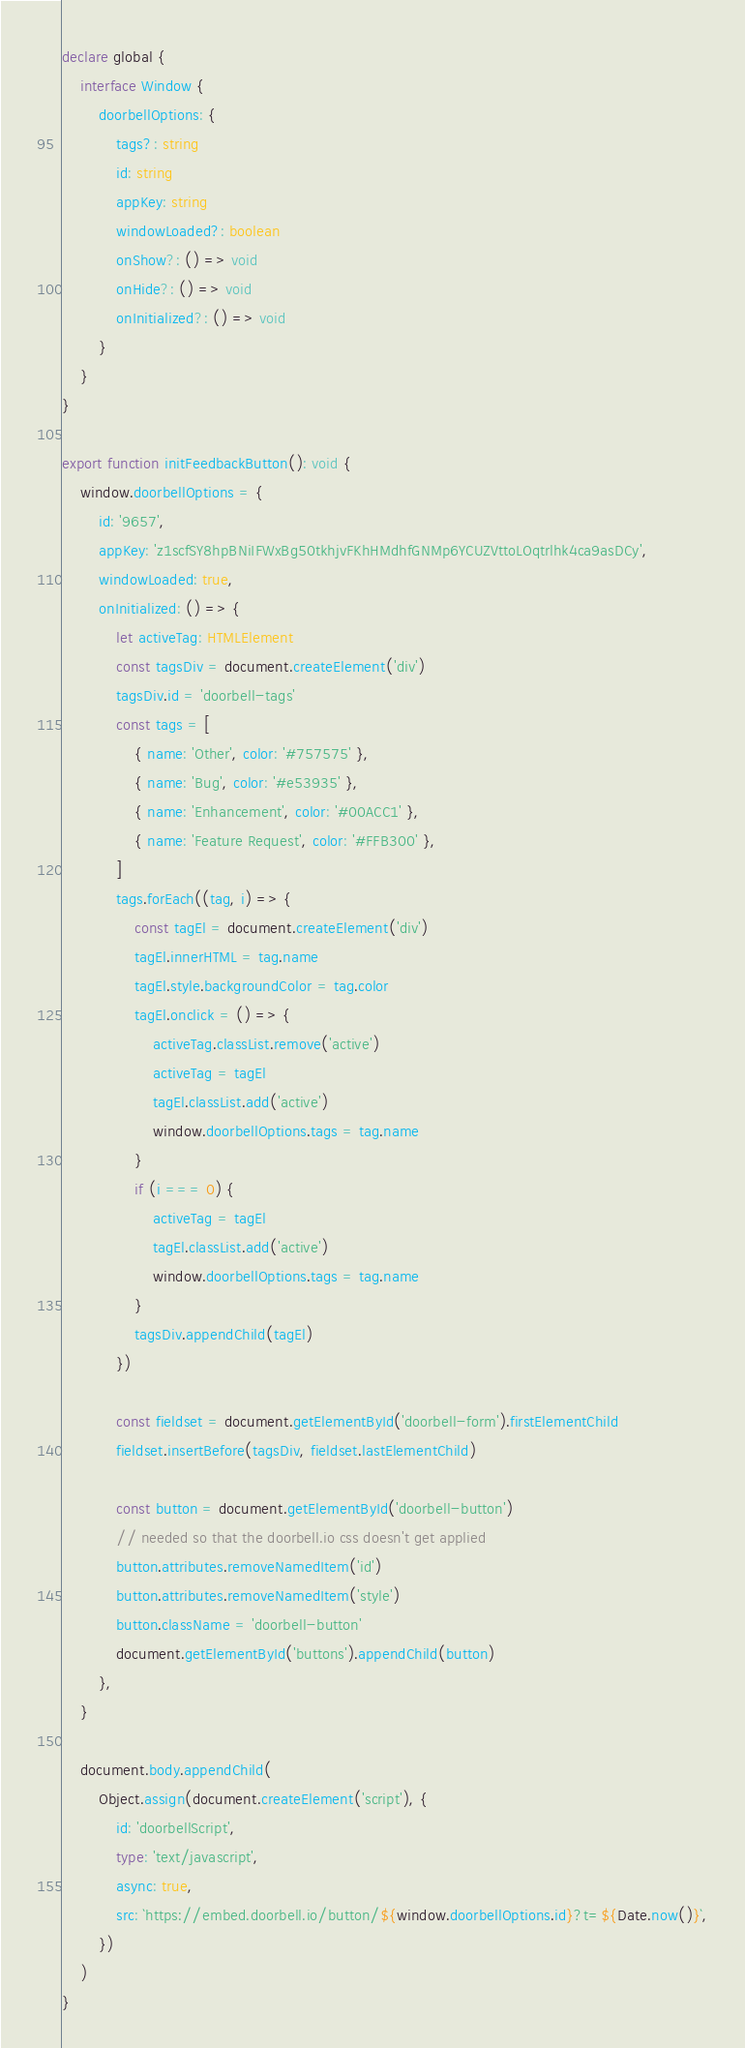Convert code to text. <code><loc_0><loc_0><loc_500><loc_500><_TypeScript_>declare global {
    interface Window {
        doorbellOptions: {
            tags?: string
            id: string
            appKey: string
            windowLoaded?: boolean
            onShow?: () => void
            onHide?: () => void
            onInitialized?: () => void
        }
    }
}

export function initFeedbackButton(): void {
    window.doorbellOptions = {
        id: '9657',
        appKey: 'z1scfSY8hpBNiIFWxBg50tkhjvFKhHMdhfGNMp6YCUZVttoLOqtrlhk4ca9asDCy',
        windowLoaded: true,
        onInitialized: () => {
            let activeTag: HTMLElement
            const tagsDiv = document.createElement('div')
            tagsDiv.id = 'doorbell-tags'
            const tags = [
                { name: 'Other', color: '#757575' },
                { name: 'Bug', color: '#e53935' },
                { name: 'Enhancement', color: '#00ACC1' },
                { name: 'Feature Request', color: '#FFB300' },
            ]
            tags.forEach((tag, i) => {
                const tagEl = document.createElement('div')
                tagEl.innerHTML = tag.name
                tagEl.style.backgroundColor = tag.color
                tagEl.onclick = () => {
                    activeTag.classList.remove('active')
                    activeTag = tagEl
                    tagEl.classList.add('active')
                    window.doorbellOptions.tags = tag.name
                }
                if (i === 0) {
                    activeTag = tagEl
                    tagEl.classList.add('active')
                    window.doorbellOptions.tags = tag.name
                }
                tagsDiv.appendChild(tagEl)
            })

            const fieldset = document.getElementById('doorbell-form').firstElementChild
            fieldset.insertBefore(tagsDiv, fieldset.lastElementChild)

            const button = document.getElementById('doorbell-button')
            // needed so that the doorbell.io css doesn't get applied
            button.attributes.removeNamedItem('id')
            button.attributes.removeNamedItem('style')
            button.className = 'doorbell-button'
            document.getElementById('buttons').appendChild(button)
        },
    }

    document.body.appendChild(
        Object.assign(document.createElement('script'), {
            id: 'doorbellScript',
            type: 'text/javascript',
            async: true,
            src: `https://embed.doorbell.io/button/${window.doorbellOptions.id}?t=${Date.now()}`,
        })
    )
}
</code> 